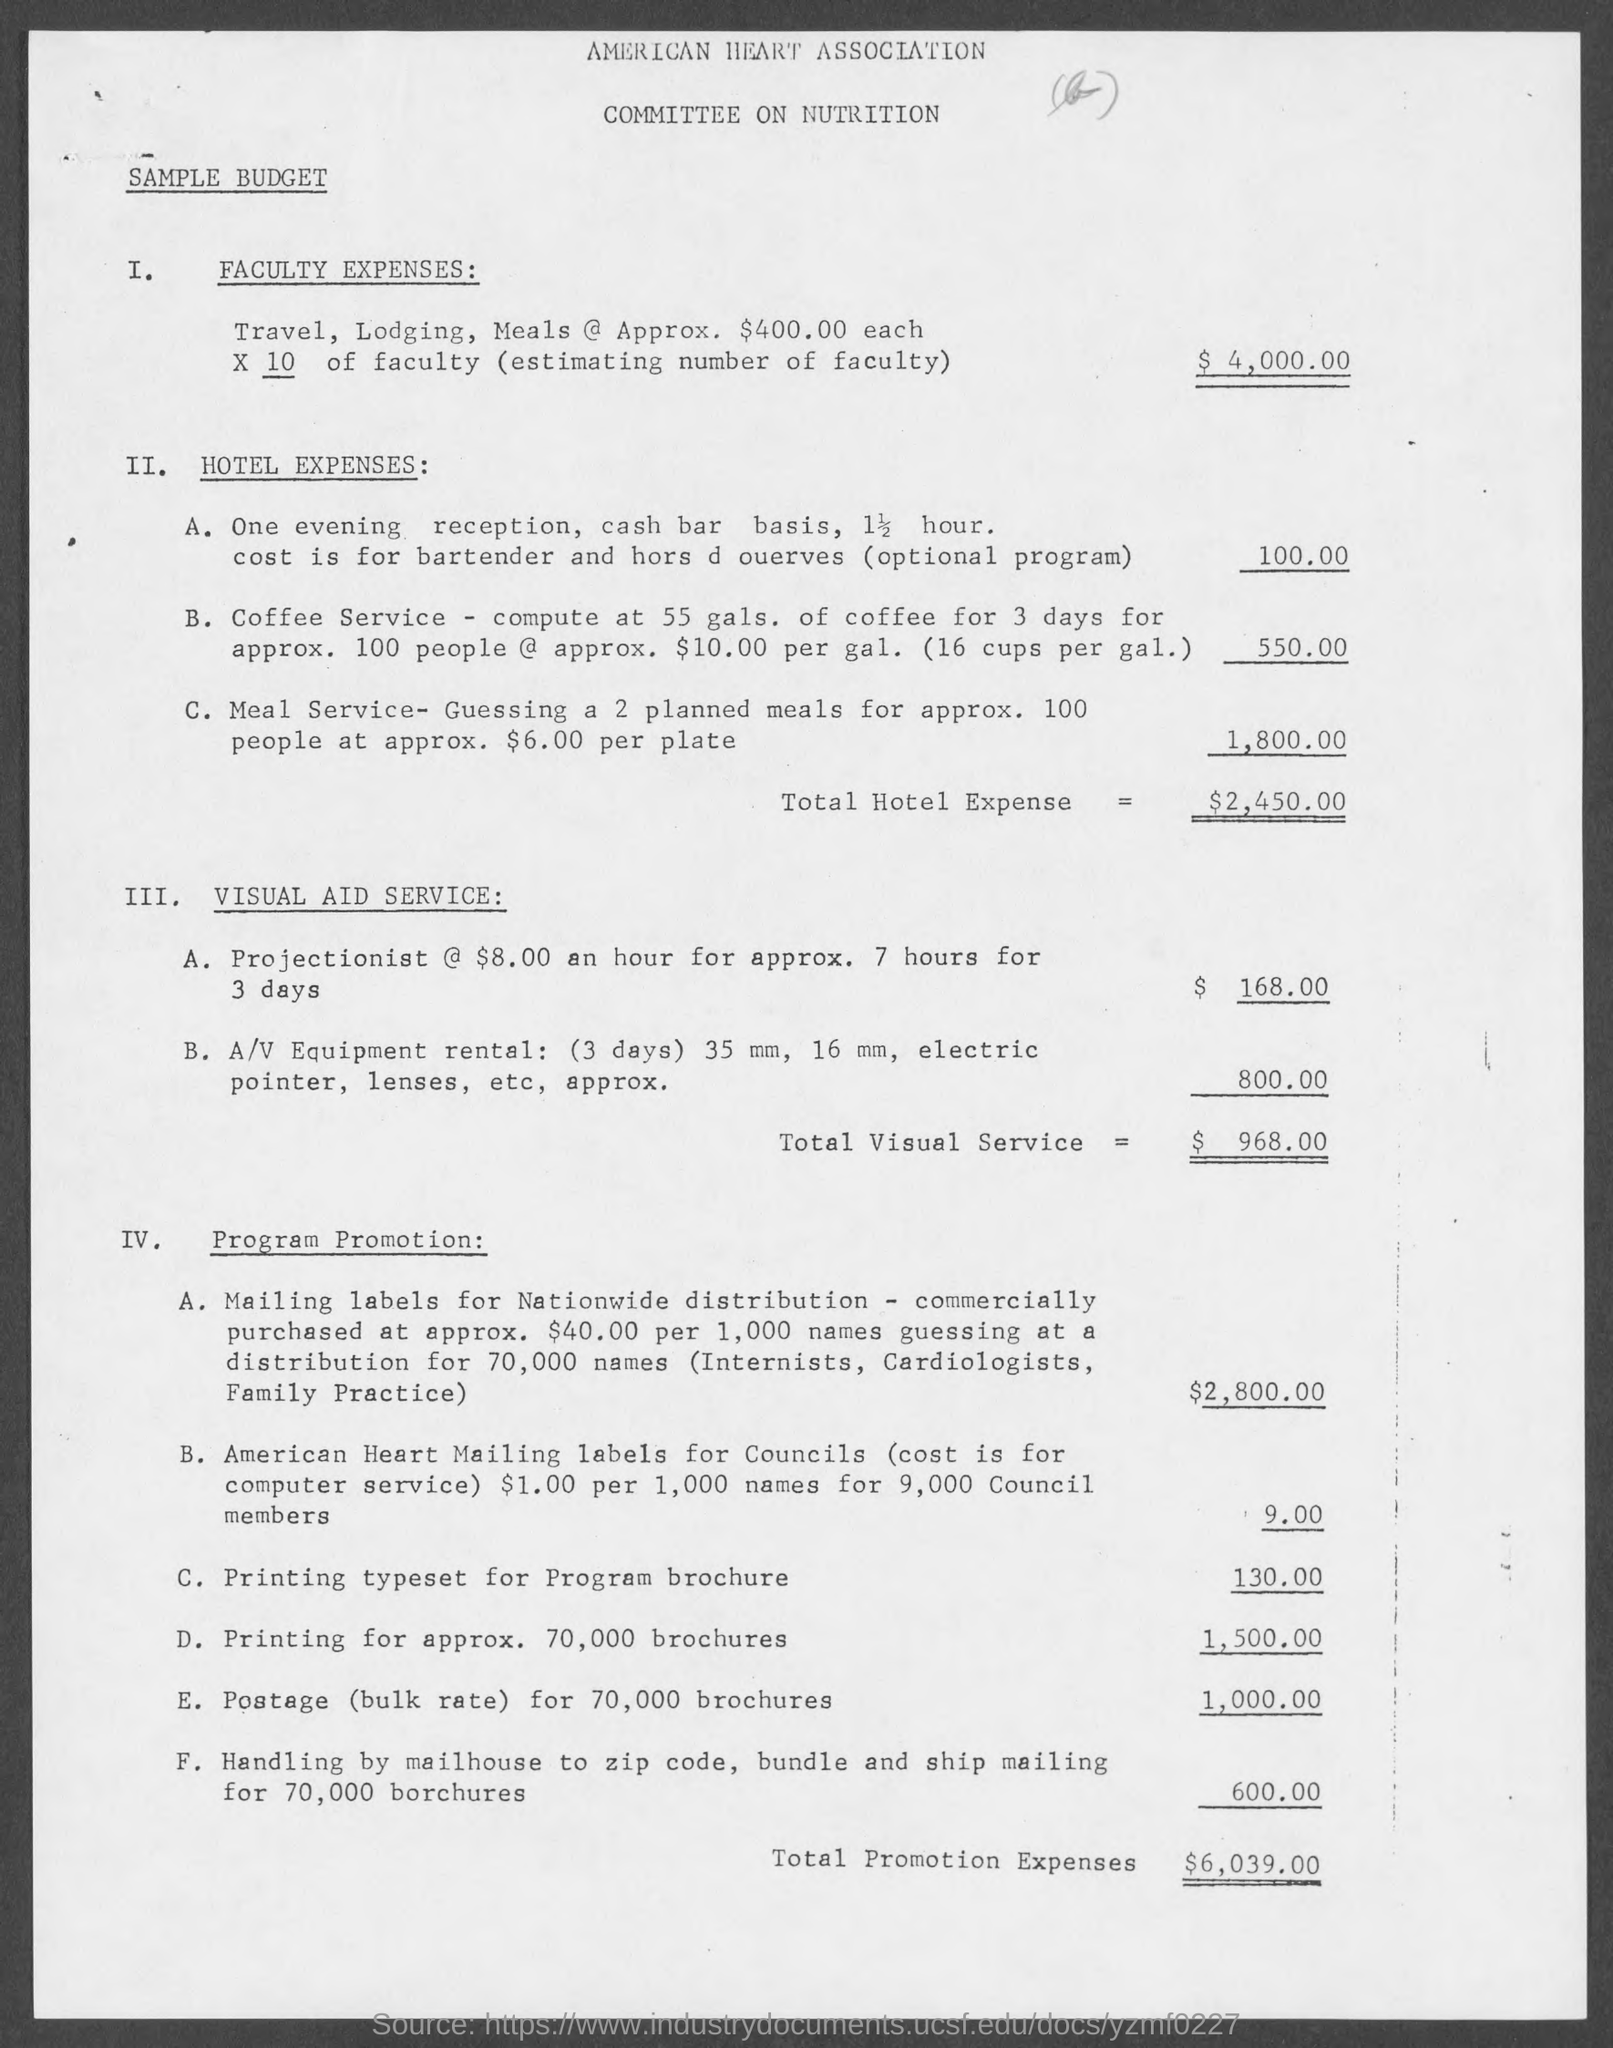How much total promotion expenses?
Your response must be concise. 6,039. 